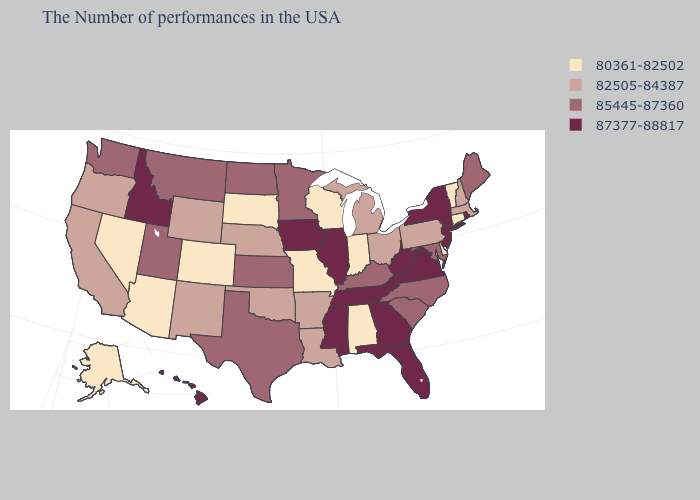Which states have the highest value in the USA?
Short answer required. Rhode Island, New York, New Jersey, Virginia, West Virginia, Florida, Georgia, Tennessee, Illinois, Mississippi, Iowa, Idaho, Hawaii. Does Georgia have the highest value in the USA?
Concise answer only. Yes. Among the states that border Louisiana , which have the lowest value?
Short answer required. Arkansas. Name the states that have a value in the range 82505-84387?
Write a very short answer. Massachusetts, New Hampshire, Pennsylvania, Ohio, Michigan, Louisiana, Arkansas, Nebraska, Oklahoma, Wyoming, New Mexico, California, Oregon. Does Alabama have the lowest value in the USA?
Quick response, please. Yes. What is the highest value in the South ?
Answer briefly. 87377-88817. Name the states that have a value in the range 80361-82502?
Short answer required. Vermont, Connecticut, Delaware, Indiana, Alabama, Wisconsin, Missouri, South Dakota, Colorado, Arizona, Nevada, Alaska. Does New Jersey have the lowest value in the Northeast?
Answer briefly. No. Which states have the lowest value in the Northeast?
Keep it brief. Vermont, Connecticut. Does New York have the highest value in the USA?
Keep it brief. Yes. Name the states that have a value in the range 85445-87360?
Quick response, please. Maine, Maryland, North Carolina, South Carolina, Kentucky, Minnesota, Kansas, Texas, North Dakota, Utah, Montana, Washington. Does the first symbol in the legend represent the smallest category?
Answer briefly. Yes. Which states have the lowest value in the Northeast?
Concise answer only. Vermont, Connecticut. Among the states that border Kansas , which have the highest value?
Short answer required. Nebraska, Oklahoma. Name the states that have a value in the range 87377-88817?
Give a very brief answer. Rhode Island, New York, New Jersey, Virginia, West Virginia, Florida, Georgia, Tennessee, Illinois, Mississippi, Iowa, Idaho, Hawaii. 